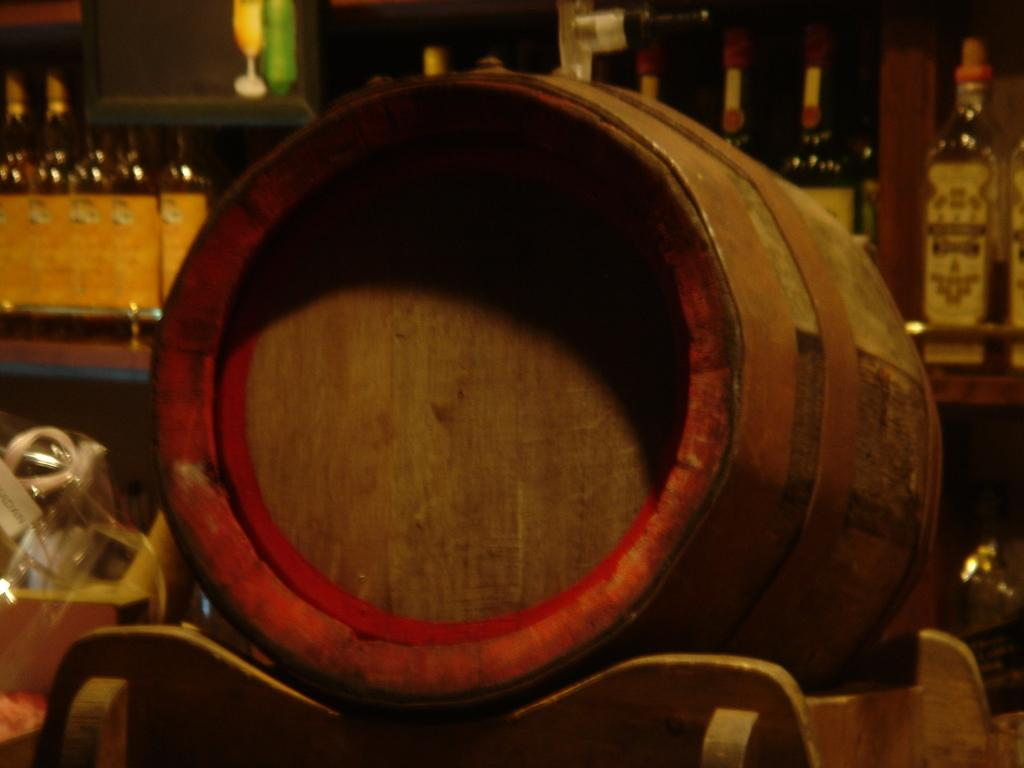What musical instrument is on the table in the image? There is a drum on the table in the image. What object is used to cover something in the image? There is a cover in the image. What type of containers can be seen in the image? There are bottles in the image. How many sisters are playing the drums in the image? There are no sisters present in the image, nor is anyone playing the drums. 